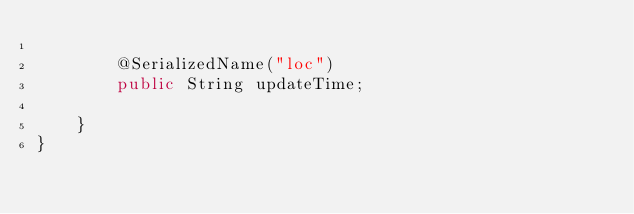Convert code to text. <code><loc_0><loc_0><loc_500><loc_500><_Java_>
        @SerializedName("loc")
        public String updateTime;

    }
}
</code> 